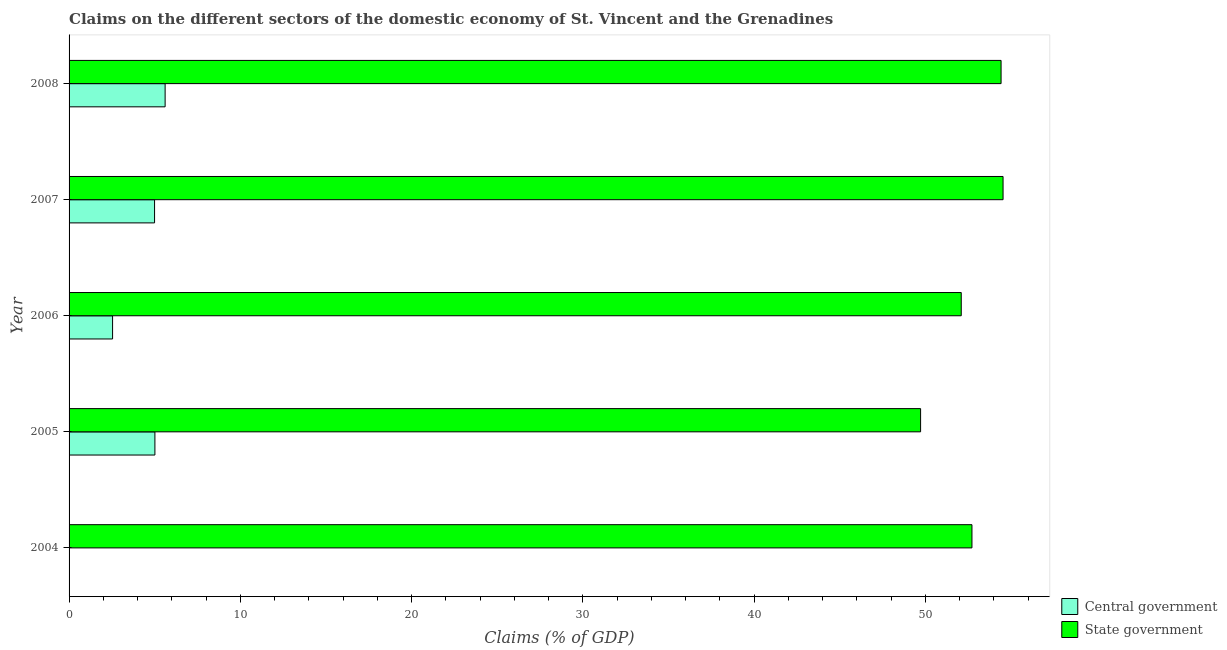How many different coloured bars are there?
Provide a short and direct response. 2. What is the label of the 4th group of bars from the top?
Your answer should be compact. 2005. In how many cases, is the number of bars for a given year not equal to the number of legend labels?
Your answer should be very brief. 1. What is the claims on state government in 2007?
Make the answer very short. 54.53. Across all years, what is the maximum claims on state government?
Give a very brief answer. 54.53. Across all years, what is the minimum claims on state government?
Provide a short and direct response. 49.72. What is the total claims on central government in the graph?
Your answer should be compact. 18.15. What is the difference between the claims on central government in 2005 and that in 2006?
Your answer should be compact. 2.47. What is the difference between the claims on central government in 2008 and the claims on state government in 2006?
Ensure brevity in your answer.  -46.48. What is the average claims on state government per year?
Provide a succinct answer. 52.7. In the year 2005, what is the difference between the claims on central government and claims on state government?
Offer a very short reply. -44.71. What is the ratio of the claims on state government in 2006 to that in 2008?
Provide a succinct answer. 0.96. Is the claims on state government in 2004 less than that in 2006?
Make the answer very short. No. Is the difference between the claims on central government in 2005 and 2006 greater than the difference between the claims on state government in 2005 and 2006?
Provide a short and direct response. Yes. What is the difference between the highest and the second highest claims on central government?
Offer a terse response. 0.6. What is the difference between the highest and the lowest claims on central government?
Provide a succinct answer. 5.61. Are all the bars in the graph horizontal?
Your answer should be very brief. Yes. How many years are there in the graph?
Offer a terse response. 5. What is the difference between two consecutive major ticks on the X-axis?
Offer a terse response. 10. Are the values on the major ticks of X-axis written in scientific E-notation?
Your answer should be very brief. No. Does the graph contain grids?
Provide a succinct answer. No. Where does the legend appear in the graph?
Your response must be concise. Bottom right. What is the title of the graph?
Your answer should be very brief. Claims on the different sectors of the domestic economy of St. Vincent and the Grenadines. Does "Register a business" appear as one of the legend labels in the graph?
Give a very brief answer. No. What is the label or title of the X-axis?
Offer a terse response. Claims (% of GDP). What is the Claims (% of GDP) of State government in 2004?
Make the answer very short. 52.72. What is the Claims (% of GDP) of Central government in 2005?
Your answer should be very brief. 5.01. What is the Claims (% of GDP) in State government in 2005?
Provide a succinct answer. 49.72. What is the Claims (% of GDP) in Central government in 2006?
Ensure brevity in your answer.  2.54. What is the Claims (% of GDP) in State government in 2006?
Ensure brevity in your answer.  52.09. What is the Claims (% of GDP) of Central government in 2007?
Ensure brevity in your answer.  4.99. What is the Claims (% of GDP) in State government in 2007?
Provide a succinct answer. 54.53. What is the Claims (% of GDP) of Central government in 2008?
Your answer should be very brief. 5.61. What is the Claims (% of GDP) of State government in 2008?
Provide a short and direct response. 54.42. Across all years, what is the maximum Claims (% of GDP) of Central government?
Keep it short and to the point. 5.61. Across all years, what is the maximum Claims (% of GDP) of State government?
Provide a succinct answer. 54.53. Across all years, what is the minimum Claims (% of GDP) in State government?
Make the answer very short. 49.72. What is the total Claims (% of GDP) of Central government in the graph?
Keep it short and to the point. 18.15. What is the total Claims (% of GDP) in State government in the graph?
Your answer should be compact. 263.48. What is the difference between the Claims (% of GDP) of State government in 2004 and that in 2005?
Your response must be concise. 3. What is the difference between the Claims (% of GDP) in State government in 2004 and that in 2006?
Offer a very short reply. 0.63. What is the difference between the Claims (% of GDP) of State government in 2004 and that in 2007?
Provide a short and direct response. -1.82. What is the difference between the Claims (% of GDP) of State government in 2004 and that in 2008?
Offer a terse response. -1.7. What is the difference between the Claims (% of GDP) in Central government in 2005 and that in 2006?
Provide a short and direct response. 2.47. What is the difference between the Claims (% of GDP) in State government in 2005 and that in 2006?
Keep it short and to the point. -2.37. What is the difference between the Claims (% of GDP) of Central government in 2005 and that in 2007?
Ensure brevity in your answer.  0.02. What is the difference between the Claims (% of GDP) of State government in 2005 and that in 2007?
Your answer should be very brief. -4.82. What is the difference between the Claims (% of GDP) of Central government in 2005 and that in 2008?
Your answer should be very brief. -0.6. What is the difference between the Claims (% of GDP) of State government in 2005 and that in 2008?
Offer a terse response. -4.7. What is the difference between the Claims (% of GDP) in Central government in 2006 and that in 2007?
Offer a terse response. -2.45. What is the difference between the Claims (% of GDP) in State government in 2006 and that in 2007?
Offer a terse response. -2.44. What is the difference between the Claims (% of GDP) in Central government in 2006 and that in 2008?
Ensure brevity in your answer.  -3.07. What is the difference between the Claims (% of GDP) of State government in 2006 and that in 2008?
Make the answer very short. -2.33. What is the difference between the Claims (% of GDP) in Central government in 2007 and that in 2008?
Give a very brief answer. -0.62. What is the difference between the Claims (% of GDP) of State government in 2007 and that in 2008?
Give a very brief answer. 0.12. What is the difference between the Claims (% of GDP) of Central government in 2005 and the Claims (% of GDP) of State government in 2006?
Make the answer very short. -47.08. What is the difference between the Claims (% of GDP) of Central government in 2005 and the Claims (% of GDP) of State government in 2007?
Your answer should be compact. -49.52. What is the difference between the Claims (% of GDP) in Central government in 2005 and the Claims (% of GDP) in State government in 2008?
Your answer should be compact. -49.41. What is the difference between the Claims (% of GDP) of Central government in 2006 and the Claims (% of GDP) of State government in 2007?
Make the answer very short. -51.99. What is the difference between the Claims (% of GDP) of Central government in 2006 and the Claims (% of GDP) of State government in 2008?
Offer a terse response. -51.88. What is the difference between the Claims (% of GDP) in Central government in 2007 and the Claims (% of GDP) in State government in 2008?
Ensure brevity in your answer.  -49.43. What is the average Claims (% of GDP) in Central government per year?
Ensure brevity in your answer.  3.63. What is the average Claims (% of GDP) in State government per year?
Your response must be concise. 52.7. In the year 2005, what is the difference between the Claims (% of GDP) of Central government and Claims (% of GDP) of State government?
Make the answer very short. -44.71. In the year 2006, what is the difference between the Claims (% of GDP) in Central government and Claims (% of GDP) in State government?
Offer a terse response. -49.55. In the year 2007, what is the difference between the Claims (% of GDP) in Central government and Claims (% of GDP) in State government?
Offer a terse response. -49.54. In the year 2008, what is the difference between the Claims (% of GDP) of Central government and Claims (% of GDP) of State government?
Make the answer very short. -48.81. What is the ratio of the Claims (% of GDP) in State government in 2004 to that in 2005?
Your response must be concise. 1.06. What is the ratio of the Claims (% of GDP) in State government in 2004 to that in 2007?
Your answer should be compact. 0.97. What is the ratio of the Claims (% of GDP) of State government in 2004 to that in 2008?
Your response must be concise. 0.97. What is the ratio of the Claims (% of GDP) of Central government in 2005 to that in 2006?
Your answer should be compact. 1.97. What is the ratio of the Claims (% of GDP) of State government in 2005 to that in 2006?
Offer a terse response. 0.95. What is the ratio of the Claims (% of GDP) in State government in 2005 to that in 2007?
Provide a succinct answer. 0.91. What is the ratio of the Claims (% of GDP) in Central government in 2005 to that in 2008?
Offer a terse response. 0.89. What is the ratio of the Claims (% of GDP) in State government in 2005 to that in 2008?
Your response must be concise. 0.91. What is the ratio of the Claims (% of GDP) in Central government in 2006 to that in 2007?
Keep it short and to the point. 0.51. What is the ratio of the Claims (% of GDP) of State government in 2006 to that in 2007?
Your response must be concise. 0.96. What is the ratio of the Claims (% of GDP) in Central government in 2006 to that in 2008?
Your response must be concise. 0.45. What is the ratio of the Claims (% of GDP) in State government in 2006 to that in 2008?
Keep it short and to the point. 0.96. What is the ratio of the Claims (% of GDP) of Central government in 2007 to that in 2008?
Your answer should be compact. 0.89. What is the ratio of the Claims (% of GDP) in State government in 2007 to that in 2008?
Provide a short and direct response. 1. What is the difference between the highest and the second highest Claims (% of GDP) in Central government?
Make the answer very short. 0.6. What is the difference between the highest and the second highest Claims (% of GDP) of State government?
Ensure brevity in your answer.  0.12. What is the difference between the highest and the lowest Claims (% of GDP) of Central government?
Offer a very short reply. 5.61. What is the difference between the highest and the lowest Claims (% of GDP) of State government?
Your answer should be compact. 4.82. 